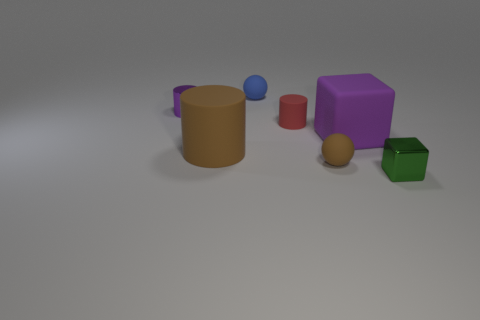There is a rubber cylinder that is the same size as the shiny cube; what color is it?
Provide a short and direct response. Red. The other thing that is the same shape as the small blue rubber object is what color?
Your answer should be compact. Brown. What number of objects are either tiny yellow things or tiny objects that are to the right of the tiny blue matte sphere?
Give a very brief answer. 3. Is the number of purple cylinders that are in front of the large brown object less than the number of small red rubber cylinders?
Offer a terse response. Yes. What is the size of the cube right of the cube behind the matte sphere in front of the large purple matte thing?
Ensure brevity in your answer.  Small. There is a small thing that is behind the large brown cylinder and in front of the purple shiny cylinder; what color is it?
Offer a terse response. Red. What number of purple rubber blocks are there?
Provide a succinct answer. 1. Is the tiny red object made of the same material as the tiny brown ball?
Provide a succinct answer. Yes. Does the ball behind the red thing have the same size as the purple matte object right of the tiny blue matte thing?
Ensure brevity in your answer.  No. Are there fewer brown rubber cylinders than cyan spheres?
Your answer should be compact. No. 